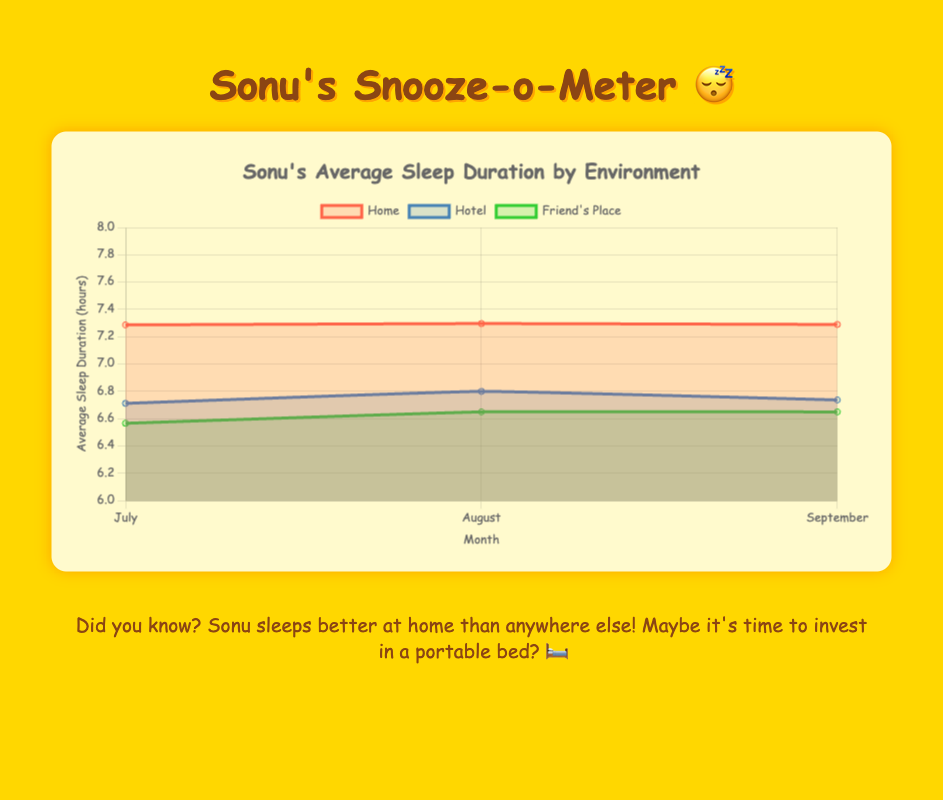What's the title of the chart? The title of the chart is displayed at the top of the figure. By looking at the figure, you can directly see the title text.
Answer: Sonu's Average Sleep Duration by Environment What do the colors on the chart represent? The different colors represent different sleeping environments. The legend in the chart explains this: red/pink for Home, blue for Hotel, and green for Friend's Place.
Answer: Different sleeping environments Which environment provided the highest average sleep in July? By looking at the July data points, you can compare the height of the areas. The Home environment has the highest point in July, indicating the highest average sleep.
Answer: Home What's the trend in average sleep duration at Hotel over the three months? By following the Hotel's line color (blue) from July to September, we can see the points for each month. The heights indicate a slight increasing trend.
Answer: Slight increase How much did Sonu’s average sleep duration at Home change from August to September? The average sleep duration for Home in August is visible and needs to be subtracted from the average in September. According to the chart, August is approximately 7.2 hours and September is about 7.3 hours. So, a difference of 0.1 hours.
Answer: 0.1 hours increase Which month did Sonu sleep the least at Hotel? By observing the lowest point in the Hotel line (blue line) on the y-axis, July has the lowest point.
Answer: July Compare Sonu’s average sleep duration between Friend's Place and Hotel in August. You can compare the heights of the green (Friend's Place) and blue (Hotel) filled areas for August by looking at their respective data points. Friend's Place is slightly lower than Hotel.
Answer: Friend's Place is lower Did Sonu’s average sleep duration at Friend's Place remain constant over the three months? Check the line for Friend's Place (green). If all three points are at the same level, it remained constant. However, the heights vary slightly, indicating it did not remain constant. It slightly fluctuates.
Answer: No Which environment shows the most variability in Sonu’s sleep patterns? By looking at the width and variability of the filled areas for each environment, Home shows the most variability as its line fluctuates more than Hotel and Friend’s Place.
Answer: Home 